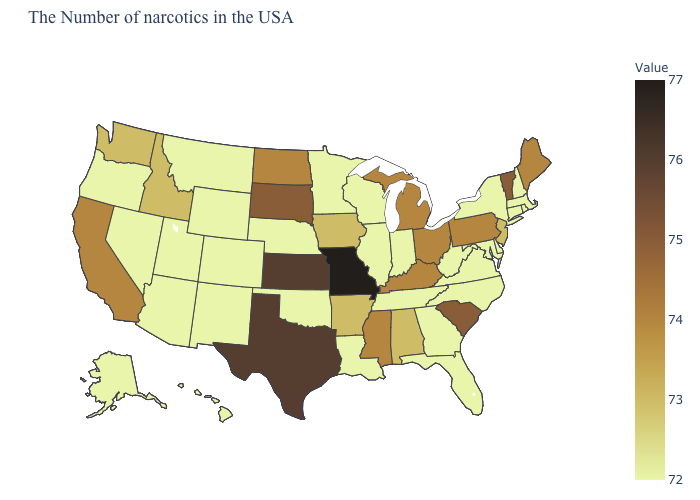Does Missouri have the highest value in the USA?
Answer briefly. Yes. Is the legend a continuous bar?
Keep it brief. Yes. Among the states that border Louisiana , which have the highest value?
Be succinct. Texas. Which states hav the highest value in the MidWest?
Keep it brief. Missouri. Among the states that border New York , does Massachusetts have the lowest value?
Give a very brief answer. Yes. Among the states that border Texas , does Arkansas have the highest value?
Quick response, please. Yes. 